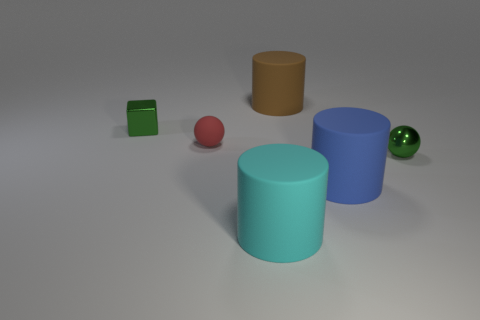Add 1 small blue cylinders. How many objects exist? 7 Subtract all cubes. How many objects are left? 5 Add 1 cylinders. How many cylinders exist? 4 Subtract 0 red cylinders. How many objects are left? 6 Subtract all big blue objects. Subtract all tiny matte things. How many objects are left? 4 Add 2 red rubber objects. How many red rubber objects are left? 3 